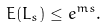<formula> <loc_0><loc_0><loc_500><loc_500>E ( L _ { s } ) \leq e ^ { m s } .</formula> 